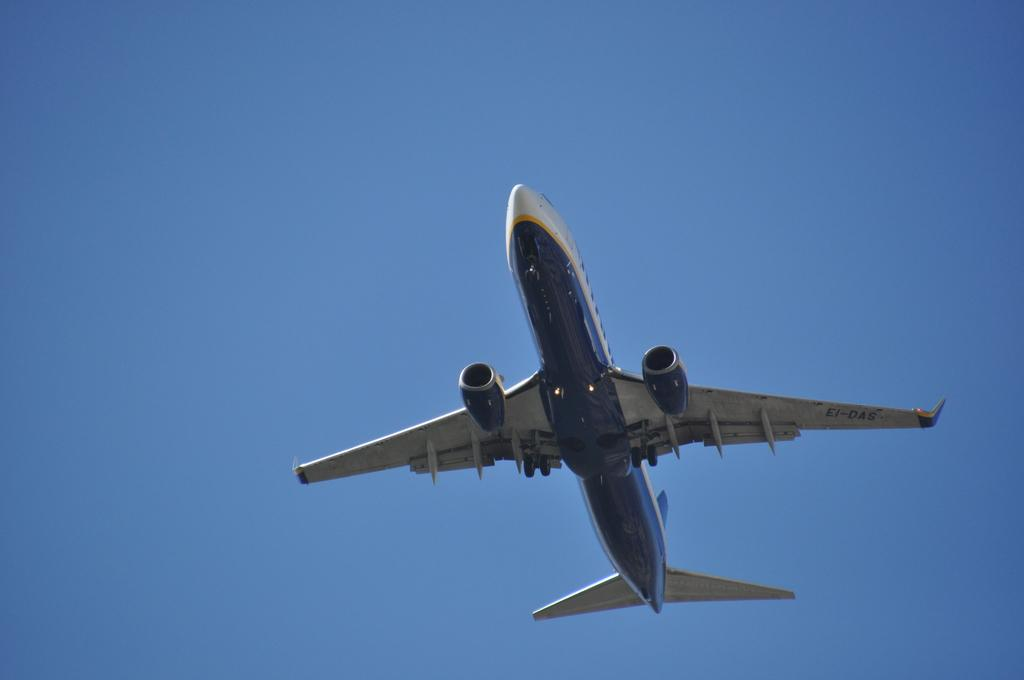What is the main subject of the picture? The main subject of the picture is an airplane. What colors are used to paint the airplane? The airplane is white and blue in color. What is the airplane doing in the image? The airplane is flying in the sky. What can be seen in the background of the image? The sky is visible in the background of the image. What is the color of the sky in the image? The sky is blue in color. Can you tell me how many notes are scattered on the ground in the image? There are no notes present in the image; it features an airplane flying in the sky. What type of soda can be seen being poured into a glass in the image? There is no soda or glass present in the image. 